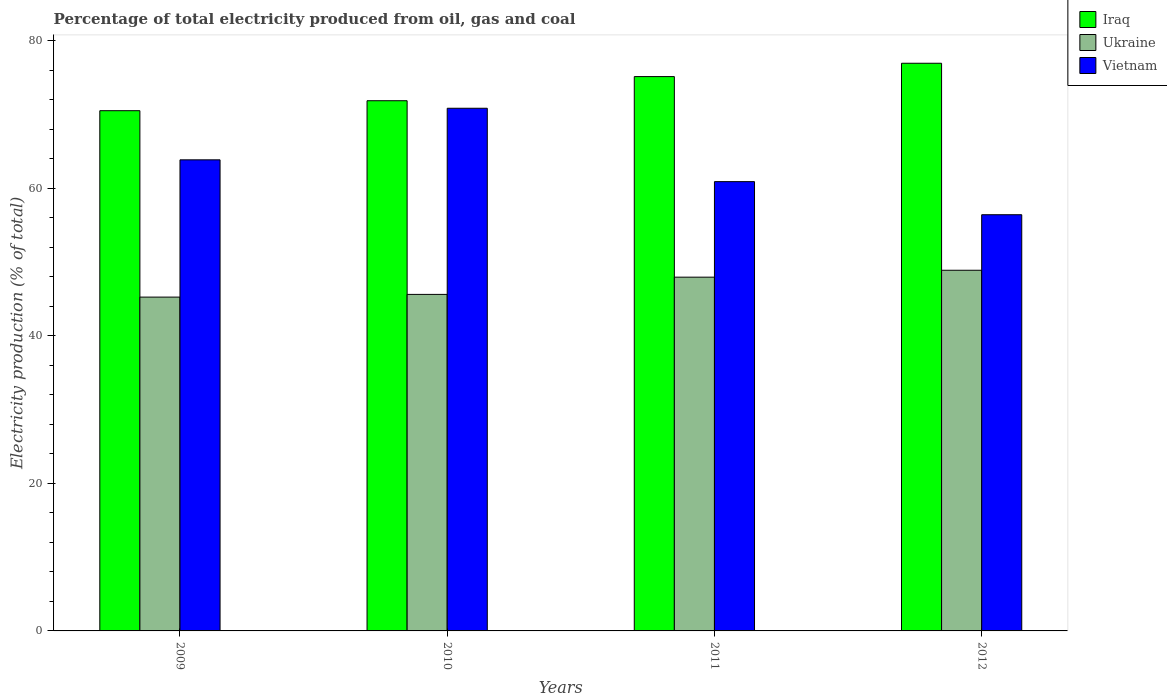How many different coloured bars are there?
Ensure brevity in your answer.  3. How many groups of bars are there?
Ensure brevity in your answer.  4. Are the number of bars on each tick of the X-axis equal?
Your answer should be very brief. Yes. How many bars are there on the 1st tick from the left?
Ensure brevity in your answer.  3. What is the label of the 3rd group of bars from the left?
Provide a short and direct response. 2011. In how many cases, is the number of bars for a given year not equal to the number of legend labels?
Your response must be concise. 0. What is the electricity production in in Vietnam in 2012?
Keep it short and to the point. 56.43. Across all years, what is the maximum electricity production in in Iraq?
Give a very brief answer. 76.96. Across all years, what is the minimum electricity production in in Ukraine?
Offer a terse response. 45.26. In which year was the electricity production in in Vietnam maximum?
Ensure brevity in your answer.  2010. What is the total electricity production in in Ukraine in the graph?
Your answer should be compact. 187.74. What is the difference between the electricity production in in Iraq in 2009 and that in 2011?
Provide a short and direct response. -4.62. What is the difference between the electricity production in in Vietnam in 2011 and the electricity production in in Ukraine in 2012?
Ensure brevity in your answer.  12.02. What is the average electricity production in in Iraq per year?
Your answer should be compact. 73.63. In the year 2012, what is the difference between the electricity production in in Iraq and electricity production in in Ukraine?
Your answer should be compact. 28.06. In how many years, is the electricity production in in Iraq greater than 68 %?
Offer a very short reply. 4. What is the ratio of the electricity production in in Ukraine in 2009 to that in 2010?
Your response must be concise. 0.99. Is the electricity production in in Iraq in 2011 less than that in 2012?
Provide a short and direct response. Yes. Is the difference between the electricity production in in Iraq in 2010 and 2012 greater than the difference between the electricity production in in Ukraine in 2010 and 2012?
Give a very brief answer. No. What is the difference between the highest and the second highest electricity production in in Iraq?
Ensure brevity in your answer.  1.81. What is the difference between the highest and the lowest electricity production in in Ukraine?
Your response must be concise. 3.64. In how many years, is the electricity production in in Ukraine greater than the average electricity production in in Ukraine taken over all years?
Ensure brevity in your answer.  2. Is the sum of the electricity production in in Iraq in 2010 and 2012 greater than the maximum electricity production in in Vietnam across all years?
Provide a succinct answer. Yes. What does the 1st bar from the left in 2010 represents?
Ensure brevity in your answer.  Iraq. What does the 1st bar from the right in 2011 represents?
Keep it short and to the point. Vietnam. Is it the case that in every year, the sum of the electricity production in in Vietnam and electricity production in in Iraq is greater than the electricity production in in Ukraine?
Make the answer very short. Yes. Does the graph contain any zero values?
Provide a short and direct response. No. Where does the legend appear in the graph?
Offer a terse response. Top right. What is the title of the graph?
Provide a short and direct response. Percentage of total electricity produced from oil, gas and coal. What is the label or title of the Y-axis?
Ensure brevity in your answer.  Electricity production (% of total). What is the Electricity production (% of total) in Iraq in 2009?
Your answer should be very brief. 70.53. What is the Electricity production (% of total) in Ukraine in 2009?
Provide a succinct answer. 45.26. What is the Electricity production (% of total) in Vietnam in 2009?
Give a very brief answer. 63.87. What is the Electricity production (% of total) of Iraq in 2010?
Provide a succinct answer. 71.88. What is the Electricity production (% of total) in Ukraine in 2010?
Provide a short and direct response. 45.62. What is the Electricity production (% of total) in Vietnam in 2010?
Provide a succinct answer. 70.86. What is the Electricity production (% of total) in Iraq in 2011?
Offer a very short reply. 75.15. What is the Electricity production (% of total) of Ukraine in 2011?
Give a very brief answer. 47.96. What is the Electricity production (% of total) of Vietnam in 2011?
Your response must be concise. 60.91. What is the Electricity production (% of total) of Iraq in 2012?
Your answer should be compact. 76.96. What is the Electricity production (% of total) in Ukraine in 2012?
Provide a succinct answer. 48.9. What is the Electricity production (% of total) in Vietnam in 2012?
Your answer should be very brief. 56.43. Across all years, what is the maximum Electricity production (% of total) in Iraq?
Your answer should be very brief. 76.96. Across all years, what is the maximum Electricity production (% of total) in Ukraine?
Make the answer very short. 48.9. Across all years, what is the maximum Electricity production (% of total) of Vietnam?
Give a very brief answer. 70.86. Across all years, what is the minimum Electricity production (% of total) of Iraq?
Provide a short and direct response. 70.53. Across all years, what is the minimum Electricity production (% of total) of Ukraine?
Ensure brevity in your answer.  45.26. Across all years, what is the minimum Electricity production (% of total) in Vietnam?
Your response must be concise. 56.43. What is the total Electricity production (% of total) of Iraq in the graph?
Make the answer very short. 294.52. What is the total Electricity production (% of total) of Ukraine in the graph?
Make the answer very short. 187.74. What is the total Electricity production (% of total) of Vietnam in the graph?
Offer a terse response. 252.07. What is the difference between the Electricity production (% of total) in Iraq in 2009 and that in 2010?
Your response must be concise. -1.35. What is the difference between the Electricity production (% of total) of Ukraine in 2009 and that in 2010?
Keep it short and to the point. -0.37. What is the difference between the Electricity production (% of total) in Vietnam in 2009 and that in 2010?
Give a very brief answer. -6.99. What is the difference between the Electricity production (% of total) in Iraq in 2009 and that in 2011?
Keep it short and to the point. -4.62. What is the difference between the Electricity production (% of total) in Ukraine in 2009 and that in 2011?
Your answer should be compact. -2.7. What is the difference between the Electricity production (% of total) in Vietnam in 2009 and that in 2011?
Provide a short and direct response. 2.96. What is the difference between the Electricity production (% of total) in Iraq in 2009 and that in 2012?
Keep it short and to the point. -6.43. What is the difference between the Electricity production (% of total) of Ukraine in 2009 and that in 2012?
Keep it short and to the point. -3.64. What is the difference between the Electricity production (% of total) of Vietnam in 2009 and that in 2012?
Ensure brevity in your answer.  7.44. What is the difference between the Electricity production (% of total) of Iraq in 2010 and that in 2011?
Your response must be concise. -3.27. What is the difference between the Electricity production (% of total) of Ukraine in 2010 and that in 2011?
Offer a very short reply. -2.34. What is the difference between the Electricity production (% of total) in Vietnam in 2010 and that in 2011?
Your response must be concise. 9.95. What is the difference between the Electricity production (% of total) of Iraq in 2010 and that in 2012?
Make the answer very short. -5.08. What is the difference between the Electricity production (% of total) in Ukraine in 2010 and that in 2012?
Ensure brevity in your answer.  -3.27. What is the difference between the Electricity production (% of total) of Vietnam in 2010 and that in 2012?
Provide a succinct answer. 14.43. What is the difference between the Electricity production (% of total) in Iraq in 2011 and that in 2012?
Your answer should be compact. -1.81. What is the difference between the Electricity production (% of total) of Ukraine in 2011 and that in 2012?
Offer a terse response. -0.94. What is the difference between the Electricity production (% of total) in Vietnam in 2011 and that in 2012?
Make the answer very short. 4.49. What is the difference between the Electricity production (% of total) of Iraq in 2009 and the Electricity production (% of total) of Ukraine in 2010?
Keep it short and to the point. 24.9. What is the difference between the Electricity production (% of total) in Iraq in 2009 and the Electricity production (% of total) in Vietnam in 2010?
Offer a very short reply. -0.33. What is the difference between the Electricity production (% of total) of Ukraine in 2009 and the Electricity production (% of total) of Vietnam in 2010?
Offer a very short reply. -25.6. What is the difference between the Electricity production (% of total) in Iraq in 2009 and the Electricity production (% of total) in Ukraine in 2011?
Give a very brief answer. 22.57. What is the difference between the Electricity production (% of total) in Iraq in 2009 and the Electricity production (% of total) in Vietnam in 2011?
Offer a very short reply. 9.62. What is the difference between the Electricity production (% of total) in Ukraine in 2009 and the Electricity production (% of total) in Vietnam in 2011?
Keep it short and to the point. -15.65. What is the difference between the Electricity production (% of total) of Iraq in 2009 and the Electricity production (% of total) of Ukraine in 2012?
Your response must be concise. 21.63. What is the difference between the Electricity production (% of total) in Iraq in 2009 and the Electricity production (% of total) in Vietnam in 2012?
Keep it short and to the point. 14.1. What is the difference between the Electricity production (% of total) in Ukraine in 2009 and the Electricity production (% of total) in Vietnam in 2012?
Your answer should be compact. -11.17. What is the difference between the Electricity production (% of total) of Iraq in 2010 and the Electricity production (% of total) of Ukraine in 2011?
Provide a short and direct response. 23.92. What is the difference between the Electricity production (% of total) of Iraq in 2010 and the Electricity production (% of total) of Vietnam in 2011?
Keep it short and to the point. 10.97. What is the difference between the Electricity production (% of total) in Ukraine in 2010 and the Electricity production (% of total) in Vietnam in 2011?
Give a very brief answer. -15.29. What is the difference between the Electricity production (% of total) in Iraq in 2010 and the Electricity production (% of total) in Ukraine in 2012?
Your response must be concise. 22.99. What is the difference between the Electricity production (% of total) of Iraq in 2010 and the Electricity production (% of total) of Vietnam in 2012?
Your answer should be compact. 15.46. What is the difference between the Electricity production (% of total) in Ukraine in 2010 and the Electricity production (% of total) in Vietnam in 2012?
Give a very brief answer. -10.8. What is the difference between the Electricity production (% of total) in Iraq in 2011 and the Electricity production (% of total) in Ukraine in 2012?
Provide a succinct answer. 26.26. What is the difference between the Electricity production (% of total) of Iraq in 2011 and the Electricity production (% of total) of Vietnam in 2012?
Make the answer very short. 18.73. What is the difference between the Electricity production (% of total) in Ukraine in 2011 and the Electricity production (% of total) in Vietnam in 2012?
Provide a succinct answer. -8.47. What is the average Electricity production (% of total) in Iraq per year?
Your response must be concise. 73.63. What is the average Electricity production (% of total) of Ukraine per year?
Provide a succinct answer. 46.94. What is the average Electricity production (% of total) in Vietnam per year?
Offer a very short reply. 63.02. In the year 2009, what is the difference between the Electricity production (% of total) of Iraq and Electricity production (% of total) of Ukraine?
Your answer should be compact. 25.27. In the year 2009, what is the difference between the Electricity production (% of total) of Iraq and Electricity production (% of total) of Vietnam?
Keep it short and to the point. 6.66. In the year 2009, what is the difference between the Electricity production (% of total) in Ukraine and Electricity production (% of total) in Vietnam?
Provide a short and direct response. -18.61. In the year 2010, what is the difference between the Electricity production (% of total) in Iraq and Electricity production (% of total) in Ukraine?
Make the answer very short. 26.26. In the year 2010, what is the difference between the Electricity production (% of total) of Iraq and Electricity production (% of total) of Vietnam?
Ensure brevity in your answer.  1.02. In the year 2010, what is the difference between the Electricity production (% of total) of Ukraine and Electricity production (% of total) of Vietnam?
Keep it short and to the point. -25.23. In the year 2011, what is the difference between the Electricity production (% of total) of Iraq and Electricity production (% of total) of Ukraine?
Keep it short and to the point. 27.19. In the year 2011, what is the difference between the Electricity production (% of total) of Iraq and Electricity production (% of total) of Vietnam?
Give a very brief answer. 14.24. In the year 2011, what is the difference between the Electricity production (% of total) of Ukraine and Electricity production (% of total) of Vietnam?
Your response must be concise. -12.95. In the year 2012, what is the difference between the Electricity production (% of total) of Iraq and Electricity production (% of total) of Ukraine?
Offer a very short reply. 28.06. In the year 2012, what is the difference between the Electricity production (% of total) in Iraq and Electricity production (% of total) in Vietnam?
Your answer should be very brief. 20.53. In the year 2012, what is the difference between the Electricity production (% of total) of Ukraine and Electricity production (% of total) of Vietnam?
Offer a very short reply. -7.53. What is the ratio of the Electricity production (% of total) of Iraq in 2009 to that in 2010?
Keep it short and to the point. 0.98. What is the ratio of the Electricity production (% of total) in Ukraine in 2009 to that in 2010?
Your response must be concise. 0.99. What is the ratio of the Electricity production (% of total) of Vietnam in 2009 to that in 2010?
Provide a short and direct response. 0.9. What is the ratio of the Electricity production (% of total) in Iraq in 2009 to that in 2011?
Keep it short and to the point. 0.94. What is the ratio of the Electricity production (% of total) of Ukraine in 2009 to that in 2011?
Your answer should be compact. 0.94. What is the ratio of the Electricity production (% of total) in Vietnam in 2009 to that in 2011?
Keep it short and to the point. 1.05. What is the ratio of the Electricity production (% of total) in Iraq in 2009 to that in 2012?
Provide a succinct answer. 0.92. What is the ratio of the Electricity production (% of total) of Ukraine in 2009 to that in 2012?
Your answer should be compact. 0.93. What is the ratio of the Electricity production (% of total) of Vietnam in 2009 to that in 2012?
Keep it short and to the point. 1.13. What is the ratio of the Electricity production (% of total) in Iraq in 2010 to that in 2011?
Keep it short and to the point. 0.96. What is the ratio of the Electricity production (% of total) of Ukraine in 2010 to that in 2011?
Your answer should be compact. 0.95. What is the ratio of the Electricity production (% of total) of Vietnam in 2010 to that in 2011?
Ensure brevity in your answer.  1.16. What is the ratio of the Electricity production (% of total) of Iraq in 2010 to that in 2012?
Provide a succinct answer. 0.93. What is the ratio of the Electricity production (% of total) in Ukraine in 2010 to that in 2012?
Ensure brevity in your answer.  0.93. What is the ratio of the Electricity production (% of total) of Vietnam in 2010 to that in 2012?
Give a very brief answer. 1.26. What is the ratio of the Electricity production (% of total) of Iraq in 2011 to that in 2012?
Provide a succinct answer. 0.98. What is the ratio of the Electricity production (% of total) of Ukraine in 2011 to that in 2012?
Ensure brevity in your answer.  0.98. What is the ratio of the Electricity production (% of total) in Vietnam in 2011 to that in 2012?
Give a very brief answer. 1.08. What is the difference between the highest and the second highest Electricity production (% of total) in Iraq?
Provide a succinct answer. 1.81. What is the difference between the highest and the second highest Electricity production (% of total) in Ukraine?
Your response must be concise. 0.94. What is the difference between the highest and the second highest Electricity production (% of total) in Vietnam?
Ensure brevity in your answer.  6.99. What is the difference between the highest and the lowest Electricity production (% of total) in Iraq?
Give a very brief answer. 6.43. What is the difference between the highest and the lowest Electricity production (% of total) of Ukraine?
Give a very brief answer. 3.64. What is the difference between the highest and the lowest Electricity production (% of total) of Vietnam?
Make the answer very short. 14.43. 